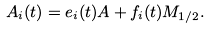<formula> <loc_0><loc_0><loc_500><loc_500>A _ { i } ( t ) = e _ { i } ( t ) A + f _ { i } ( t ) M _ { 1 / 2 } .</formula> 